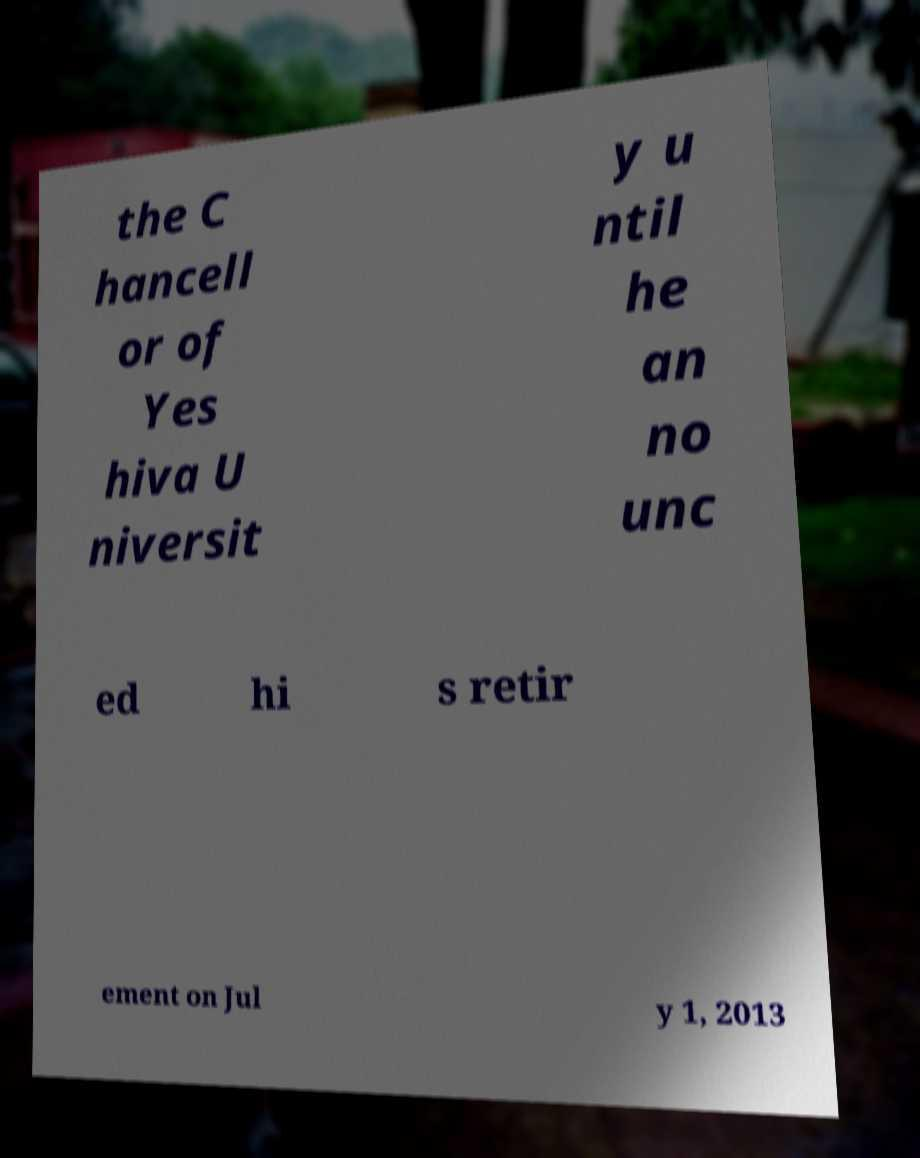Can you accurately transcribe the text from the provided image for me? the C hancell or of Yes hiva U niversit y u ntil he an no unc ed hi s retir ement on Jul y 1, 2013 